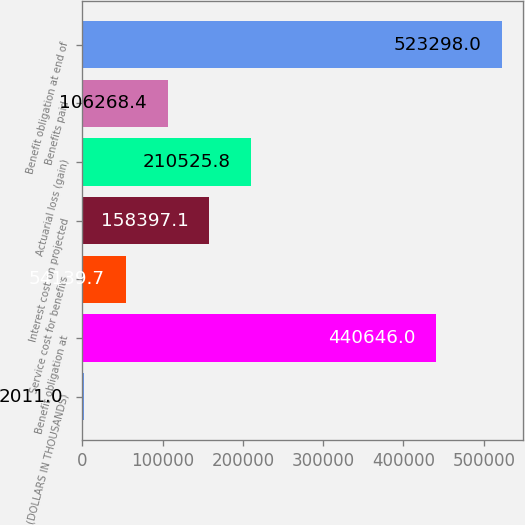Convert chart. <chart><loc_0><loc_0><loc_500><loc_500><bar_chart><fcel>(DOLLARS IN THOUSANDS)<fcel>Benefit obligation at<fcel>Service cost for benefits<fcel>Interest cost on projected<fcel>Actuarial loss (gain)<fcel>Benefits paid<fcel>Benefit obligation at end of<nl><fcel>2011<fcel>440646<fcel>54139.7<fcel>158397<fcel>210526<fcel>106268<fcel>523298<nl></chart> 